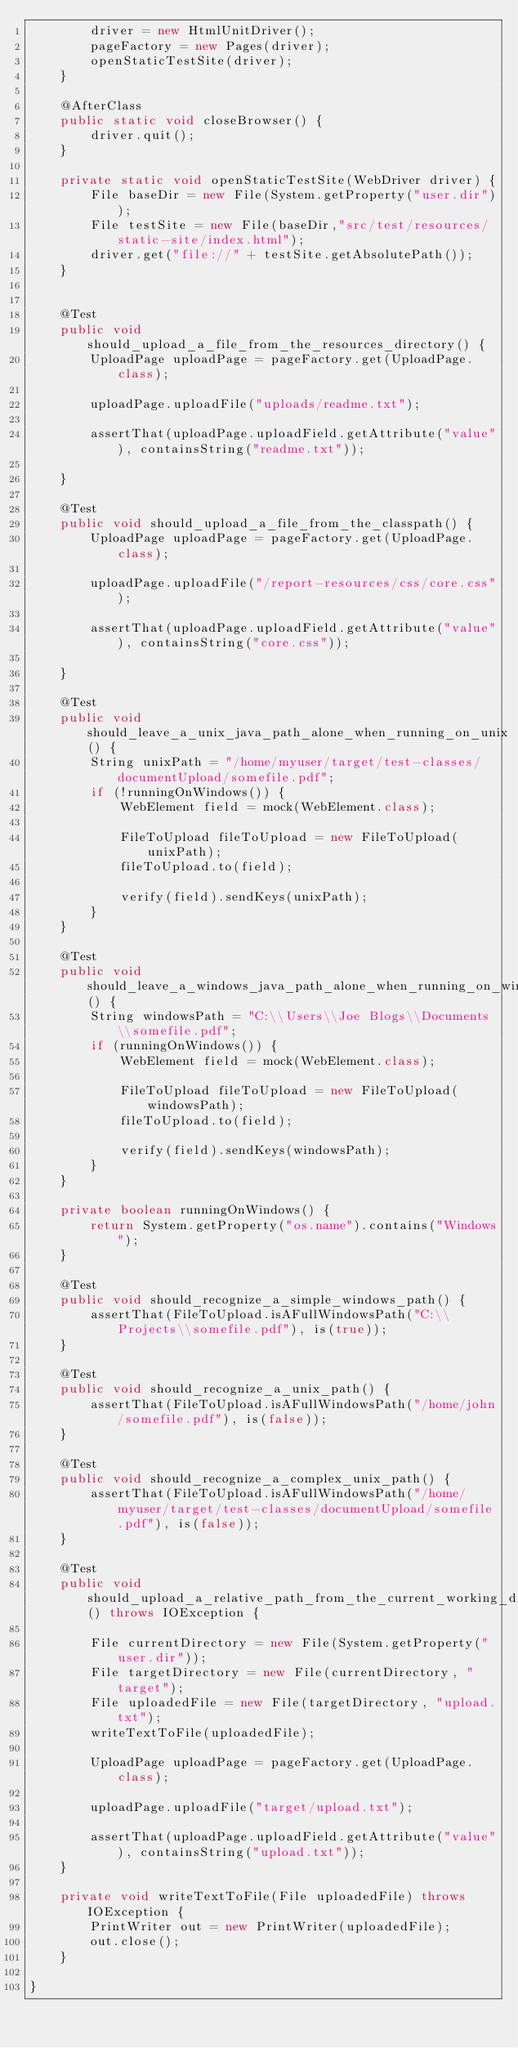<code> <loc_0><loc_0><loc_500><loc_500><_Java_>        driver = new HtmlUnitDriver();
        pageFactory = new Pages(driver);
        openStaticTestSite(driver);
    }

    @AfterClass
    public static void closeBrowser() {
        driver.quit();
    }

    private static void openStaticTestSite(WebDriver driver) {
        File baseDir = new File(System.getProperty("user.dir"));
        File testSite = new File(baseDir,"src/test/resources/static-site/index.html");
        driver.get("file://" + testSite.getAbsolutePath());
    }


    @Test
    public void should_upload_a_file_from_the_resources_directory() {
        UploadPage uploadPage = pageFactory.get(UploadPage.class);

        uploadPage.uploadFile("uploads/readme.txt");

        assertThat(uploadPage.uploadField.getAttribute("value"), containsString("readme.txt"));

    }

    @Test
    public void should_upload_a_file_from_the_classpath() {
        UploadPage uploadPage = pageFactory.get(UploadPage.class);

        uploadPage.uploadFile("/report-resources/css/core.css");

        assertThat(uploadPage.uploadField.getAttribute("value"), containsString("core.css"));

    }

    @Test
    public void should_leave_a_unix_java_path_alone_when_running_on_unix() {
        String unixPath = "/home/myuser/target/test-classes/documentUpload/somefile.pdf";
        if (!runningOnWindows()) {
            WebElement field = mock(WebElement.class);

            FileToUpload fileToUpload = new FileToUpload(unixPath);
            fileToUpload.to(field);

            verify(field).sendKeys(unixPath);
        }
    }

    @Test
    public void should_leave_a_windows_java_path_alone_when_running_on_windows() {
        String windowsPath = "C:\\Users\\Joe Blogs\\Documents\\somefile.pdf";
        if (runningOnWindows()) {
            WebElement field = mock(WebElement.class);

            FileToUpload fileToUpload = new FileToUpload(windowsPath);
            fileToUpload.to(field);

            verify(field).sendKeys(windowsPath);
        }
    }

    private boolean runningOnWindows() {
        return System.getProperty("os.name").contains("Windows");
    }

    @Test
    public void should_recognize_a_simple_windows_path() {
        assertThat(FileToUpload.isAFullWindowsPath("C:\\Projects\\somefile.pdf"), is(true));
    }

    @Test
    public void should_recognize_a_unix_path() {
        assertThat(FileToUpload.isAFullWindowsPath("/home/john/somefile.pdf"), is(false));
    }

    @Test
    public void should_recognize_a_complex_unix_path() {
        assertThat(FileToUpload.isAFullWindowsPath("/home/myuser/target/test-classes/documentUpload/somefile.pdf"), is(false));
    }

    @Test
    public void should_upload_a_relative_path_from_the_current_working_directory() throws IOException {

        File currentDirectory = new File(System.getProperty("user.dir"));
        File targetDirectory = new File(currentDirectory, "target");
        File uploadedFile = new File(targetDirectory, "upload.txt");
        writeTextToFile(uploadedFile);

        UploadPage uploadPage = pageFactory.get(UploadPage.class);

        uploadPage.uploadFile("target/upload.txt");

        assertThat(uploadPage.uploadField.getAttribute("value"), containsString("upload.txt"));
    }

    private void writeTextToFile(File uploadedFile) throws IOException {
        PrintWriter out = new PrintWriter(uploadedFile);
        out.close();
    }

}
</code> 